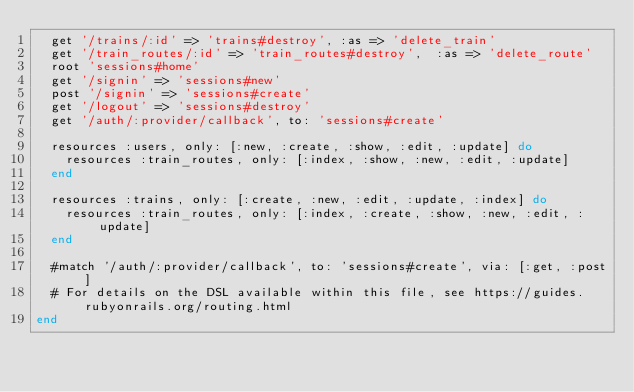Convert code to text. <code><loc_0><loc_0><loc_500><loc_500><_Ruby_>  get '/trains/:id' => 'trains#destroy', :as => 'delete_train'
  get '/train_routes/:id' => 'train_routes#destroy',  :as => 'delete_route'
  root 'sessions#home'
  get '/signin' => 'sessions#new'
  post '/signin' => 'sessions#create'
  get '/logout' => 'sessions#destroy'
  get '/auth/:provider/callback', to: 'sessions#create'

  resources :users, only: [:new, :create, :show, :edit, :update] do
    resources :train_routes, only: [:index, :show, :new, :edit, :update]
  end

  resources :trains, only: [:create, :new, :edit, :update, :index] do
    resources :train_routes, only: [:index, :create, :show, :new, :edit, :update]
  end
  
  #match '/auth/:provider/callback', to: 'sessions#create', via: [:get, :post]
  # For details on the DSL available within this file, see https://guides.rubyonrails.org/routing.html
end
</code> 